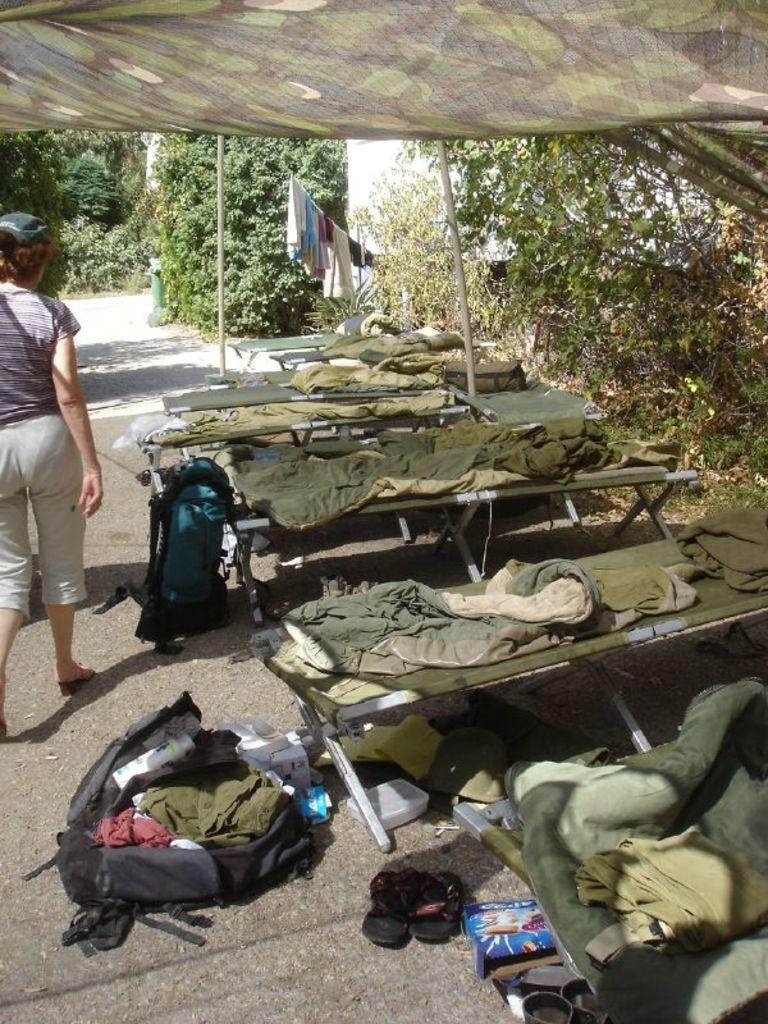What is happening on the road in the image? There is a person on the road in the image. What objects are present in the image for sitting? There are benches in the image. What item is the person carrying in the image? There is a backpack in the image. What can be seen in the distance in the image? There are trees visible in the background of the image. What type of butter is being spread on the benches in the image? There is no butter present in the image, and the benches are not being used for spreading butter. 